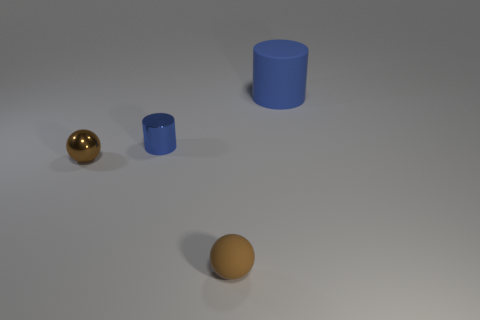Add 3 brown rubber things. How many objects exist? 7 Subtract 0 red cubes. How many objects are left? 4 Subtract all tiny metallic cylinders. Subtract all big yellow blocks. How many objects are left? 3 Add 4 tiny brown balls. How many tiny brown balls are left? 6 Add 3 tiny brown matte spheres. How many tiny brown matte spheres exist? 4 